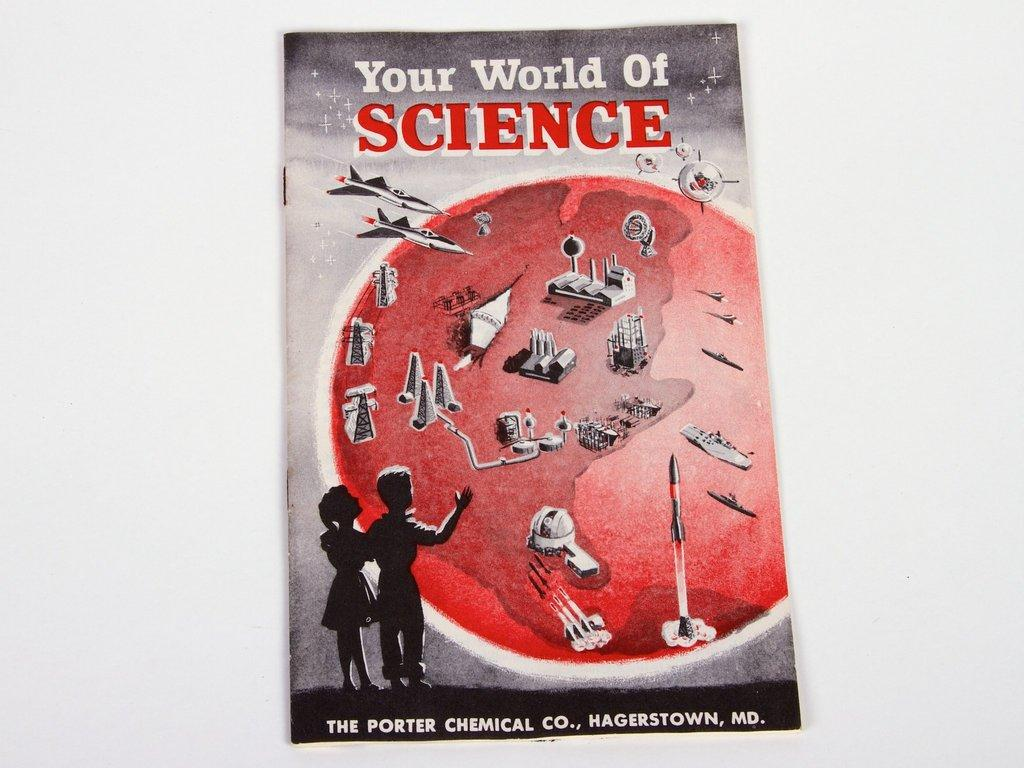<image>
Offer a succinct explanation of the picture presented. Your world of Science book from The Porter Chemical Co Hagerstown, MD. 